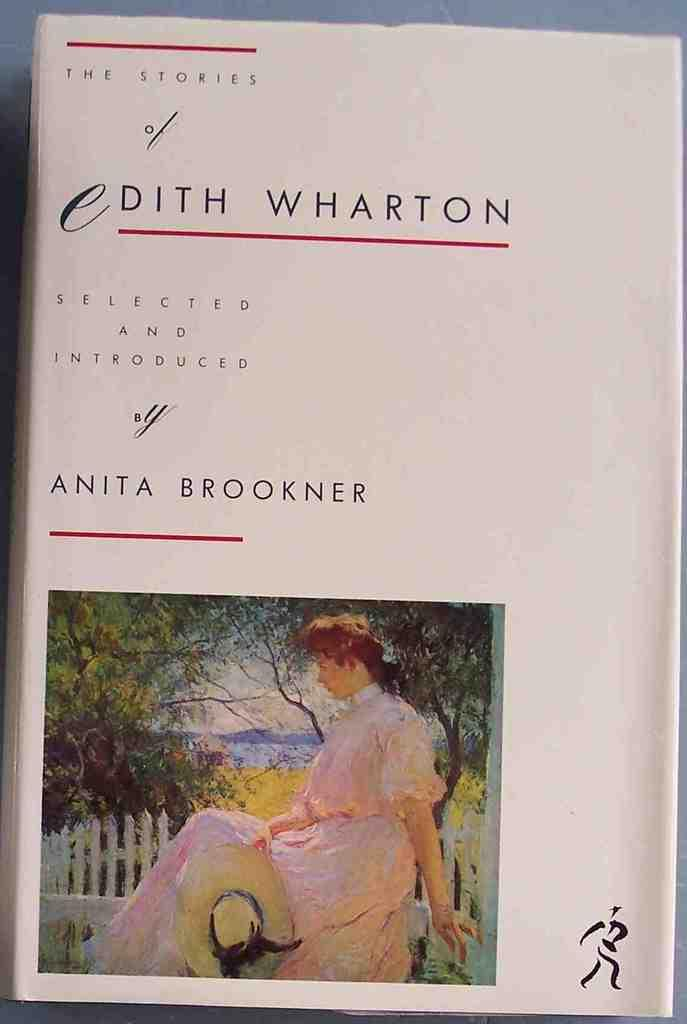<image>
Provide a brief description of the given image. A white book about Edith Wharton stories has a painting of a woman on the cover. 